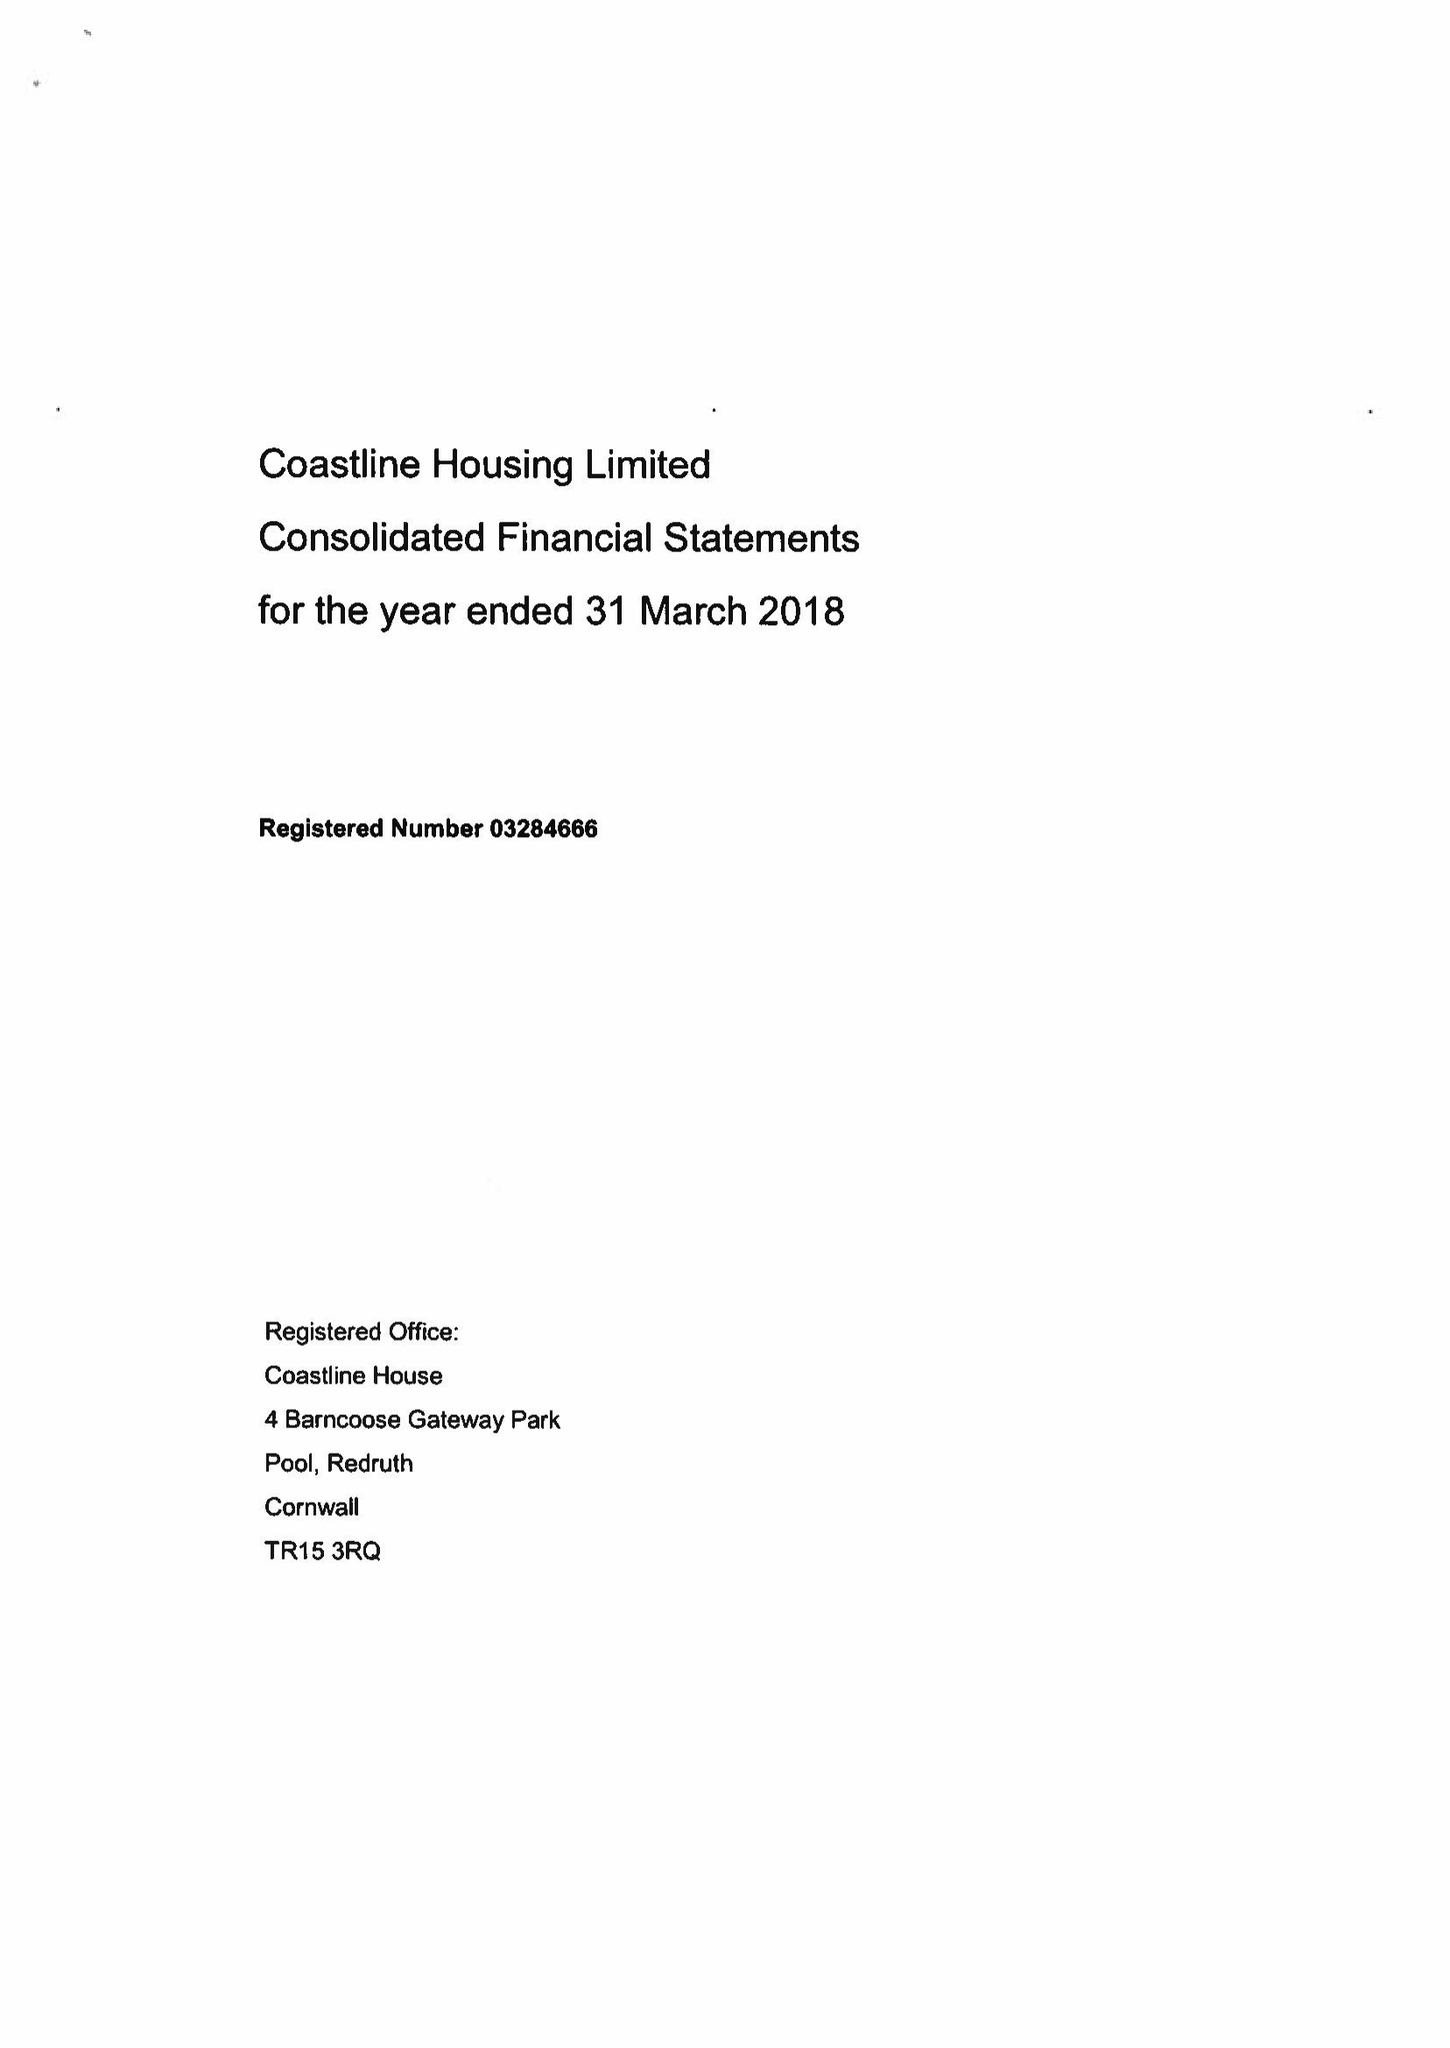What is the value for the report_date?
Answer the question using a single word or phrase. 2018-03-31 